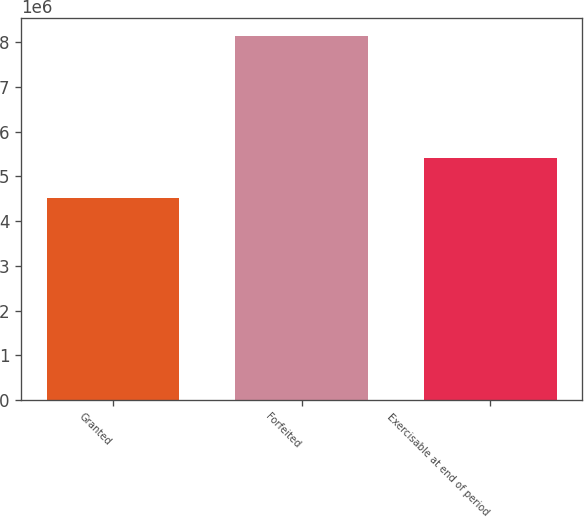Convert chart to OTSL. <chart><loc_0><loc_0><loc_500><loc_500><bar_chart><fcel>Granted<fcel>Forfeited<fcel>Exercisable at end of period<nl><fcel>4.51661e+06<fcel>8.13244e+06<fcel>5.41036e+06<nl></chart> 